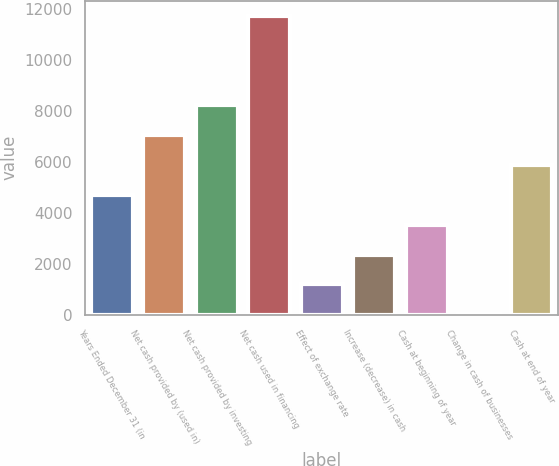<chart> <loc_0><loc_0><loc_500><loc_500><bar_chart><fcel>Years Ended December 31 (in<fcel>Net cash provided by (used in)<fcel>Net cash provided by investing<fcel>Net cash used in financing<fcel>Effect of exchange rate<fcel>Increase (decrease) in cash<fcel>Cash at beginning of year<fcel>Change in cash of businesses<fcel>Cash at end of year<nl><fcel>4717.6<fcel>7064.4<fcel>8237.8<fcel>11758<fcel>1197.4<fcel>2370.8<fcel>3544.2<fcel>24<fcel>5891<nl></chart> 